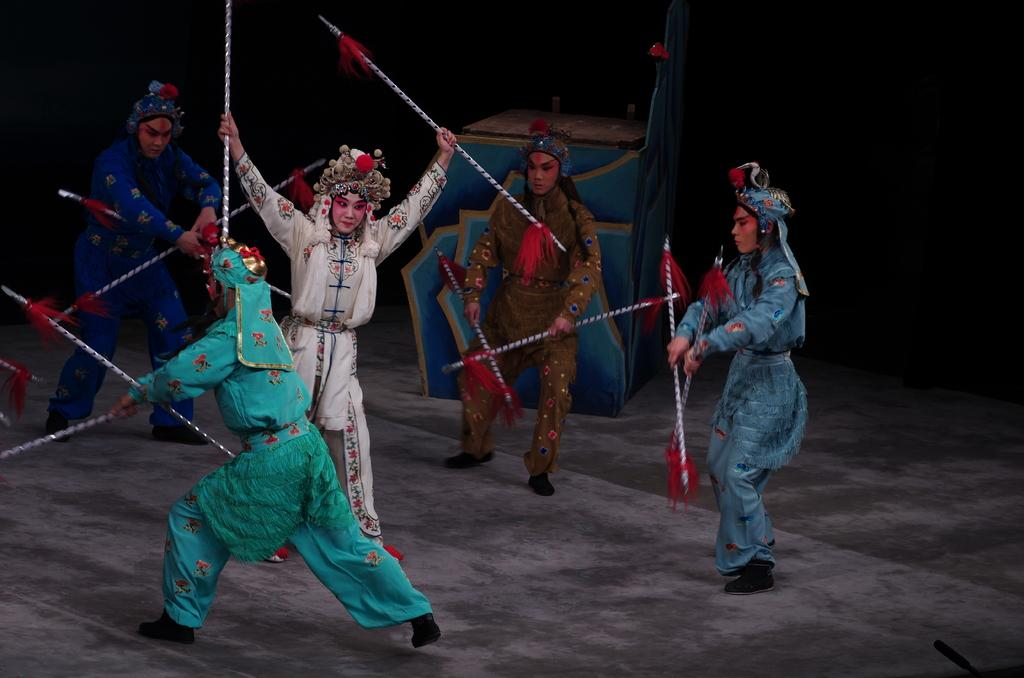How many people are in the image? There are people in the image, but the exact number is not specified. What are the people holding in their hands? The people are holding sticks in their hands. How are the people dressed? The people are dressed differently. What activity are the people engaged in? They are performing a play. What can be seen in the background of the image? There is a wooden structure in the background. Where is the bucket located in the image? There is no bucket present in the image. What type of chair can be seen in the background? There is no chair present in the image. 